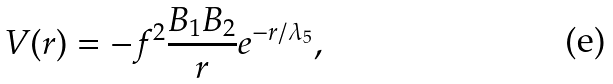Convert formula to latex. <formula><loc_0><loc_0><loc_500><loc_500>V ( r ) = - f ^ { 2 } \frac { B _ { 1 } B _ { 2 } } { r } e ^ { - r / \lambda _ { 5 } } ,</formula> 